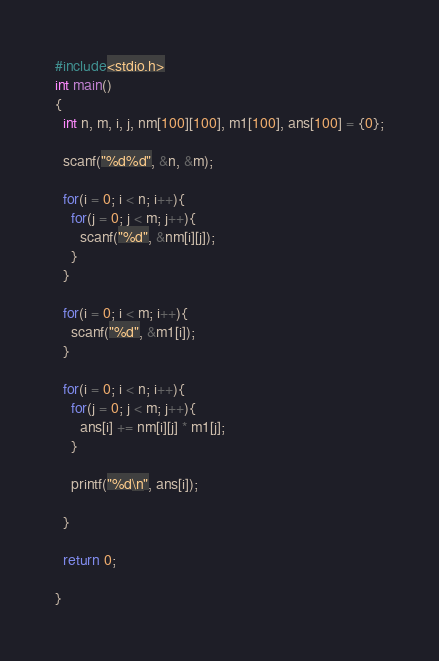Convert code to text. <code><loc_0><loc_0><loc_500><loc_500><_C_>#include<stdio.h>
int main()
{
  int n, m, i, j, nm[100][100], m1[100], ans[100] = {0};

  scanf("%d%d", &n, &m);

  for(i = 0; i < n; i++){
    for(j = 0; j < m; j++){
      scanf("%d", &nm[i][j]);
    }
  }

  for(i = 0; i < m; i++){
    scanf("%d", &m1[i]);
  }

  for(i = 0; i < n; i++){
    for(j = 0; j < m; j++){
      ans[i] += nm[i][j] * m1[j];
    }

    printf("%d\n", ans[i]);
    
  }
  
  return 0;

}</code> 